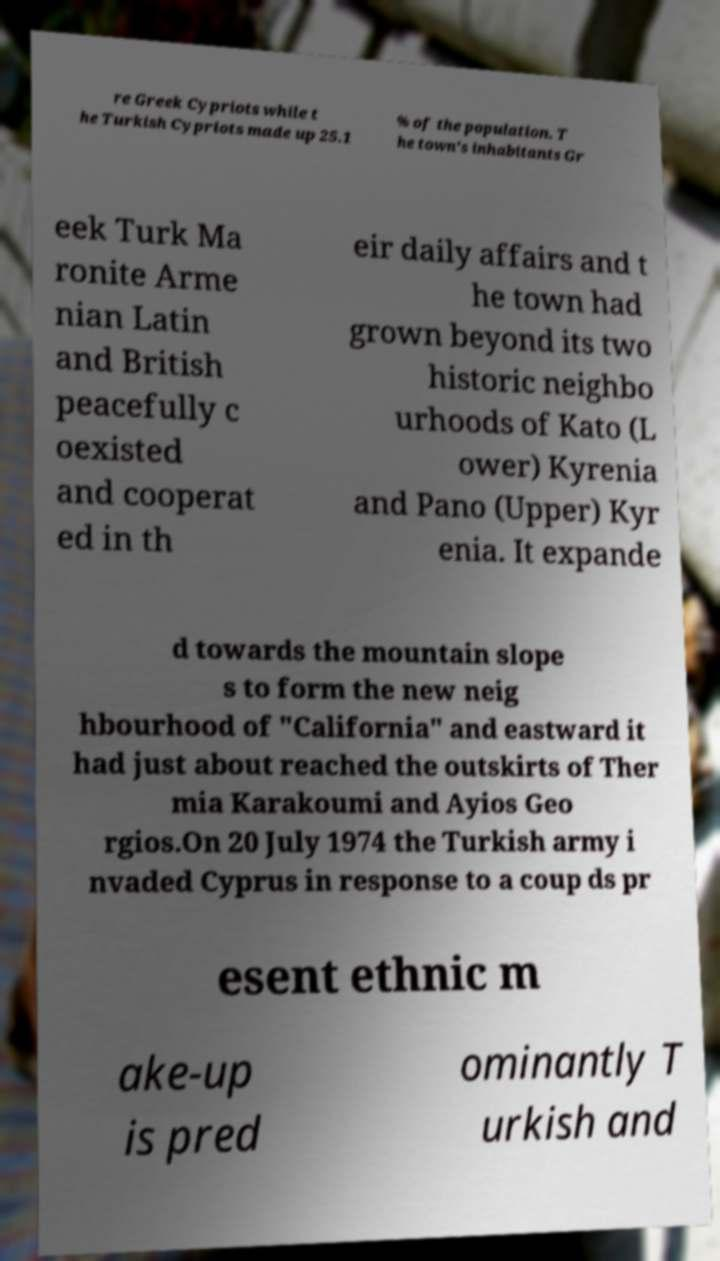Can you accurately transcribe the text from the provided image for me? re Greek Cypriots while t he Turkish Cypriots made up 25.1 % of the population. T he town's inhabitants Gr eek Turk Ma ronite Arme nian Latin and British peacefully c oexisted and cooperat ed in th eir daily affairs and t he town had grown beyond its two historic neighbo urhoods of Kato (L ower) Kyrenia and Pano (Upper) Kyr enia. It expande d towards the mountain slope s to form the new neig hbourhood of "California" and eastward it had just about reached the outskirts of Ther mia Karakoumi and Ayios Geo rgios.On 20 July 1974 the Turkish army i nvaded Cyprus in response to a coup ds pr esent ethnic m ake-up is pred ominantly T urkish and 